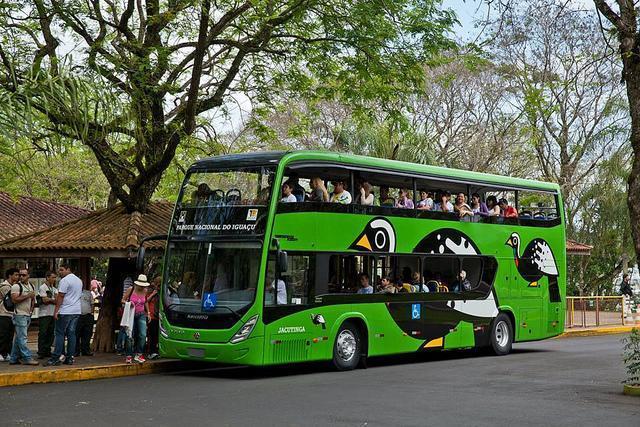How many people are in the photo?
Give a very brief answer. 2. 